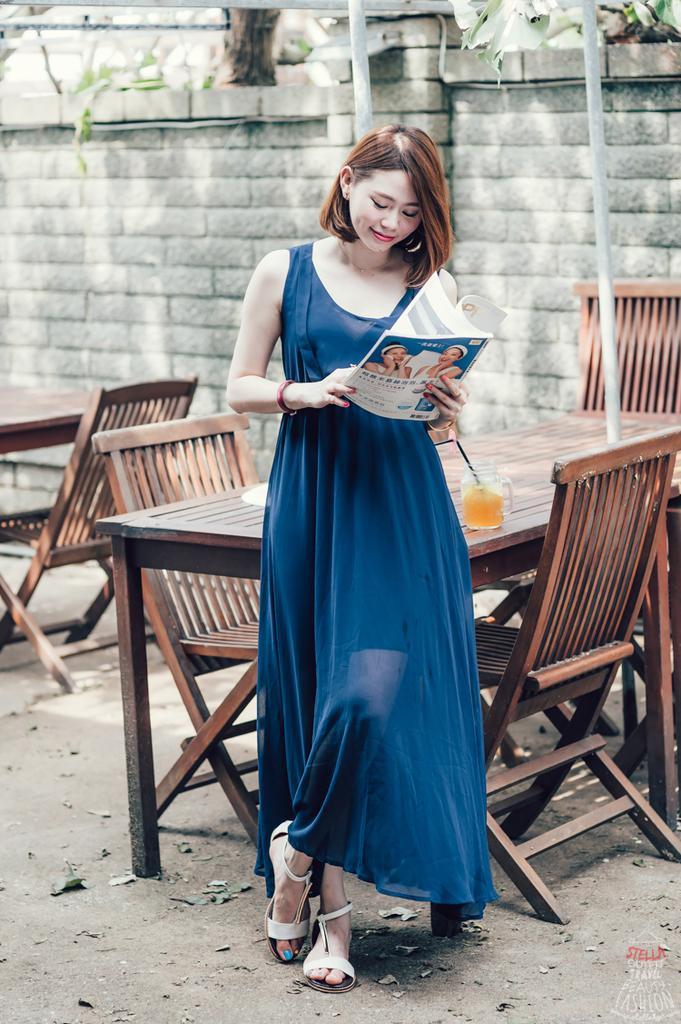How would you summarize this image in a sentence or two? A woman in blue gown is holding a book. Beside her there is a table and some chairs. On the table there is a glass with juice and straw. In the background there is a brick wall. 